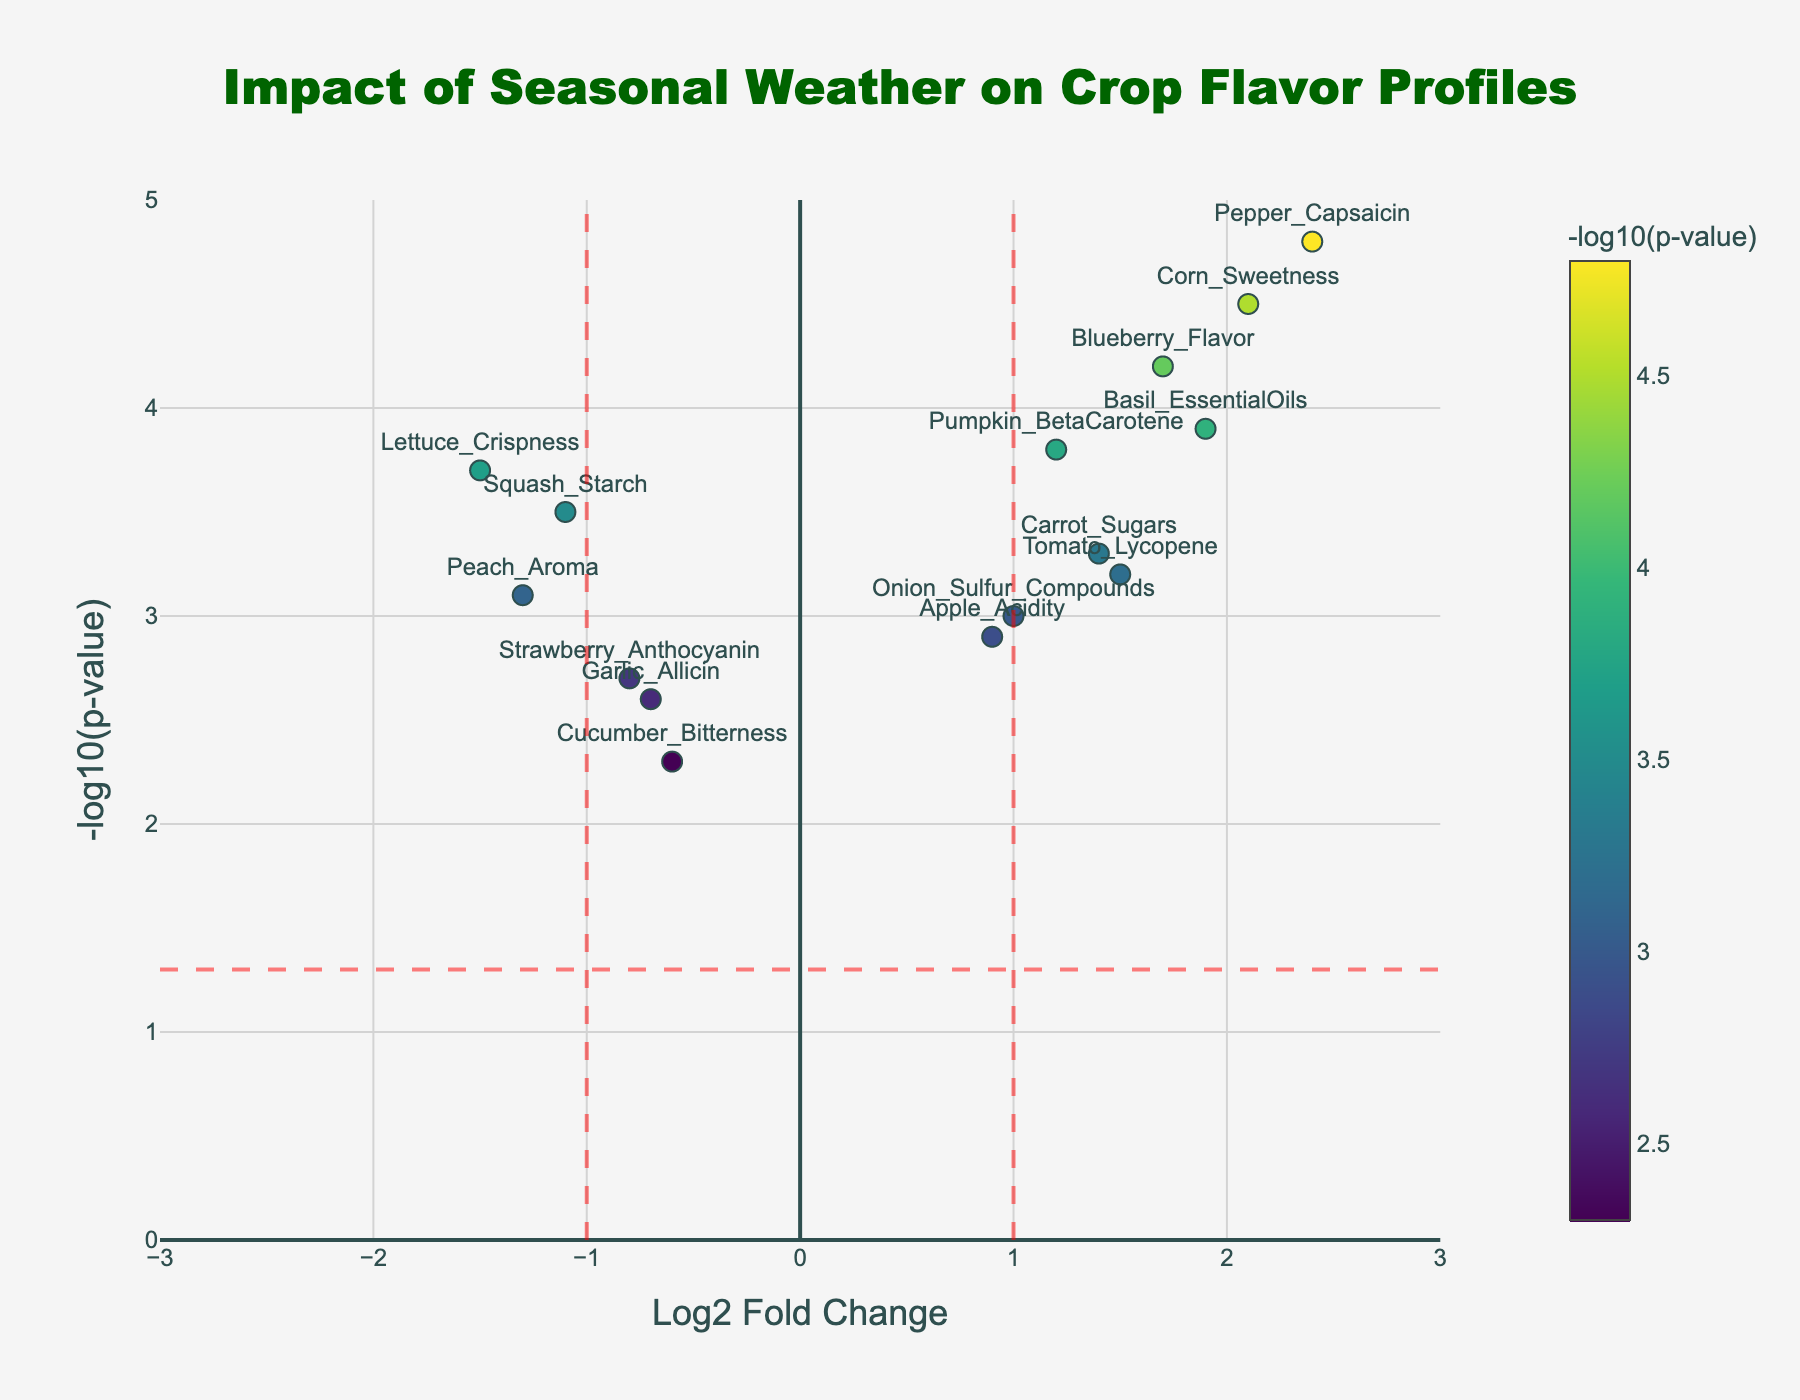What is the title of the plot? The title of the plot is located at the top and is in large, dark green, Arial Black font. It reads "Impact of Seasonal Weather on Crop Flavor Profiles."
Answer: Impact of Seasonal Weather on Crop Flavor Profiles How many data points have a Log2 Fold Change greater than 1? To determine this, we need to count the data points that have a Log2 Fold Change greater than 1. These include Tomato_Lycopene, Corn_Sweetness, Pepper_Capsaicin, Basil_EssentialOils, Blueberry_Flavor, and Carrot_Sugars. There are 6 such points.
Answer: 6 Which data point has the highest -log10(p-value)? We identify the data point with the highest value on the y-axis, which is the -log10(p-value). The highest value is 4.8, corresponding to Pepper_Capsaicin.
Answer: Pepper_Capsaicin What is the log2 fold change and -log10(p-value) for Blueberry_Flavor? Locate the Blueberry_Flavor data point on the plot. Its hover text shows the Log2 Fold Change is 1.7 and the -log10(p-value) is 4.2.
Answer: 1.7 and 4.2 Which data point has the lowest log2 fold change? To find this, look for the data point furthest to the left on the x-axis. This point is Lettuce_Crispness with a log2 fold change of -1.5.
Answer: Lettuce_Crispness How many data points are considered significant with a p-value less than 0.05? Data points with a p-value less than 0.05 have a -log10(p-value) greater than 1.3 (since -log10(0.05) ≈ 1.3). Count the points with -log10(p-values) above this threshold. All data points fall into this category. Therefore, 14 are significant.
Answer: 14 Which data points have a positive Log2 Fold Change but a -log10(p-value) below 3? From the plot, identify the points where Log2 Fold Change is greater than 0 and -log10(p-value) is less than 3. These points are Apple_Acidity with Log2 Fold Change of 0.9 and -log10(p-value) of 2.9, and Tomato_Lycopene with Log2 Fold Change of 1.5 and -log10(p-value) of 3.2. They are none.
Answer: None What is the value of the threshold line for p-value and how is it represented? The threshold line for p-value is represented as a horizontal dashed red line at y = -log10(0.05), approximately 1.3 on the y-axis. This marks the significance level typically used in statistical tests.
Answer: 1.3 Which flavor profile has a negative Log2 Fold Change and a -log10(p-value) greater than 3? To answer this, locate points where Log2 Fold Change is negative and -log10(p-value) is greater than 3. These include Strawberry_Anthocyanin, Peach_Aroma, Squash_Starch, Lettuce_Crispness. These profiles reflect diminished concentrations in the specified seasonal conditions.
Answer: Strawberry_Anthocyanin, Peach_Aroma, Squash_Starch, Lettuce_Crispness 